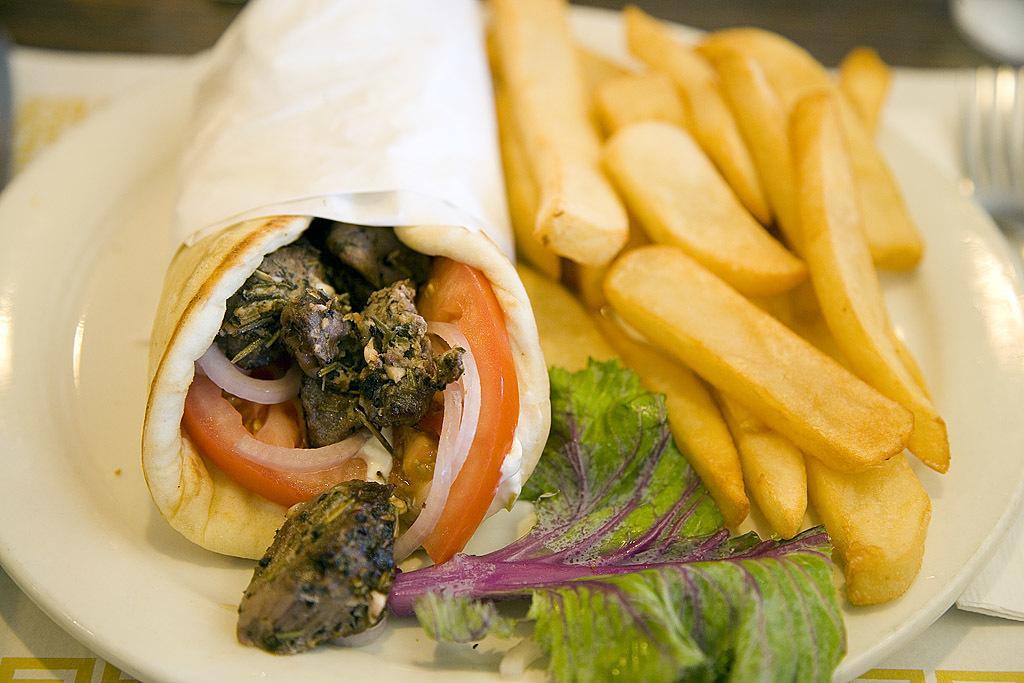Could you give a brief overview of what you see in this image? In this image on a plate there are few french fries, a leaf and a roll is there. In the table there is fork, tissues. Inside the roll there are onion, tomato and meat. 